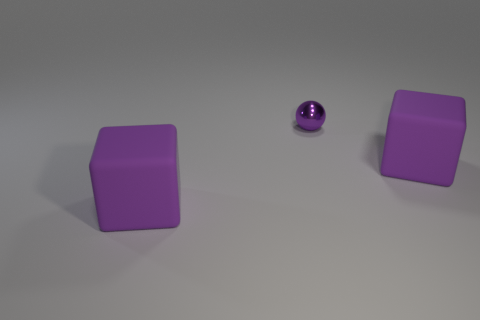Is there any other thing that has the same shape as the purple metal object?
Provide a succinct answer. No. Is there any other thing that is the same size as the purple metal ball?
Keep it short and to the point. No. What number of purple rubber objects are both left of the metal sphere and right of the purple sphere?
Give a very brief answer. 0. How many matte objects are big yellow spheres or purple things?
Provide a succinct answer. 2. What is the size of the purple cube that is right of the purple thing that is to the left of the small purple thing?
Offer a terse response. Large. Is there a big matte thing that is right of the tiny shiny thing that is on the left side of the purple rubber block right of the tiny purple thing?
Your response must be concise. Yes. Is the material of the cube that is right of the metallic ball the same as the object to the left of the tiny ball?
Keep it short and to the point. Yes. What number of things are either large gray rubber objects or large purple rubber cubes on the left side of the tiny purple thing?
Make the answer very short. 1. How many big rubber things have the same shape as the tiny metallic thing?
Keep it short and to the point. 0. There is a rubber cube in front of the large purple object that is behind the cube left of the small metal thing; what is its size?
Provide a short and direct response. Large. 